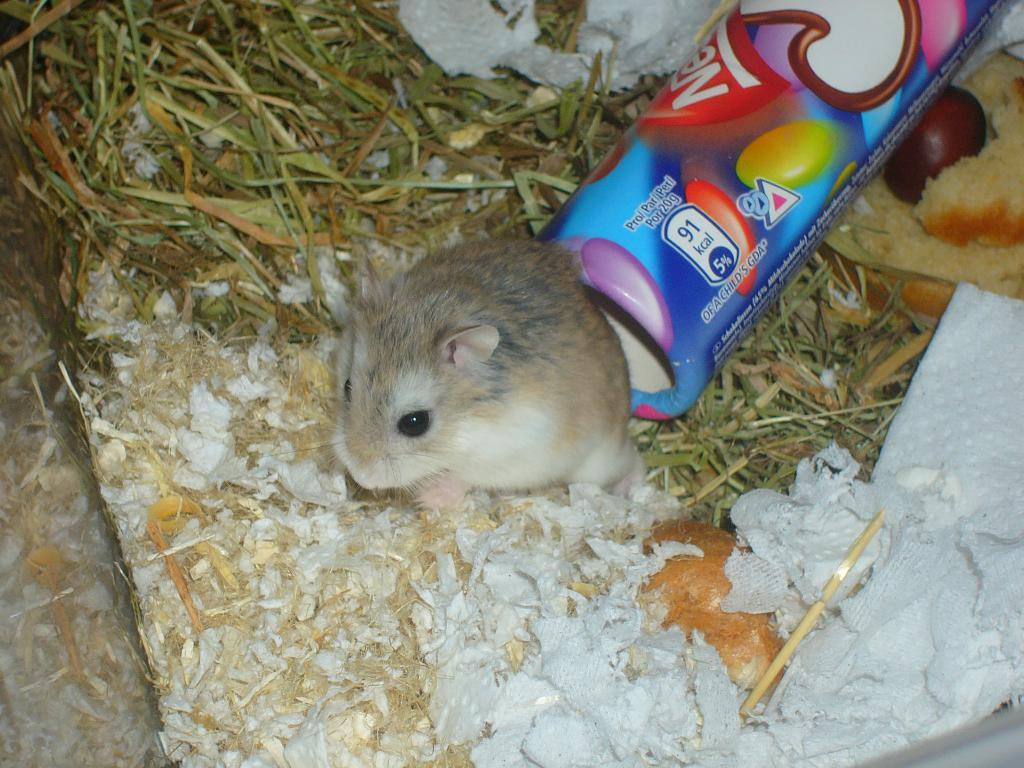What type of animal is in the image? There is a mice in the image. What material is present in the image? There is tissue paper in the image. What type of vegetation is in the image? There is grass in the image. Can you describe any other items in the image? There are other unspecified items in the image. What is the best way to solve the riddle on the mountain in the image? There is no mountain or riddle present in the image, so it is not possible to answer that question. 